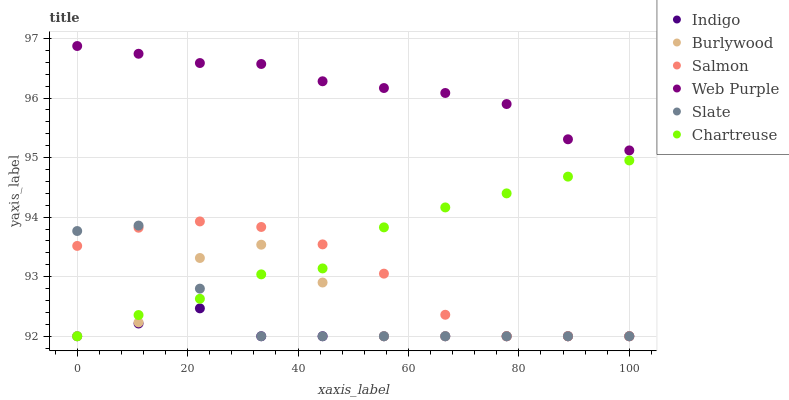Does Indigo have the minimum area under the curve?
Answer yes or no. Yes. Does Web Purple have the maximum area under the curve?
Answer yes or no. Yes. Does Burlywood have the minimum area under the curve?
Answer yes or no. No. Does Burlywood have the maximum area under the curve?
Answer yes or no. No. Is Indigo the smoothest?
Answer yes or no. Yes. Is Burlywood the roughest?
Answer yes or no. Yes. Is Slate the smoothest?
Answer yes or no. No. Is Slate the roughest?
Answer yes or no. No. Does Indigo have the lowest value?
Answer yes or no. Yes. Does Web Purple have the lowest value?
Answer yes or no. No. Does Web Purple have the highest value?
Answer yes or no. Yes. Does Burlywood have the highest value?
Answer yes or no. No. Is Burlywood less than Web Purple?
Answer yes or no. Yes. Is Web Purple greater than Slate?
Answer yes or no. Yes. Does Slate intersect Burlywood?
Answer yes or no. Yes. Is Slate less than Burlywood?
Answer yes or no. No. Is Slate greater than Burlywood?
Answer yes or no. No. Does Burlywood intersect Web Purple?
Answer yes or no. No. 